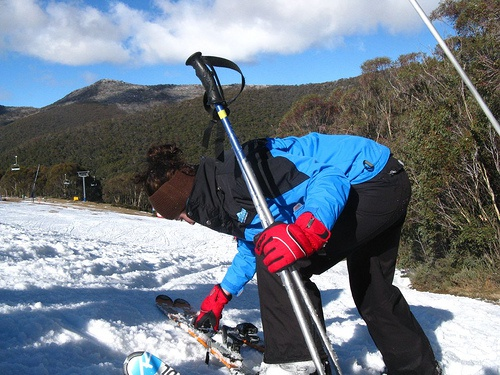Describe the objects in this image and their specific colors. I can see people in darkgray, black, lightblue, and white tones, skis in darkgray, black, gray, and lightgray tones, and skis in darkgray, white, lightblue, and gray tones in this image. 